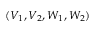Convert formula to latex. <formula><loc_0><loc_0><loc_500><loc_500>( V _ { 1 } , V _ { 2 } , W _ { 1 } , W _ { 2 } )</formula> 